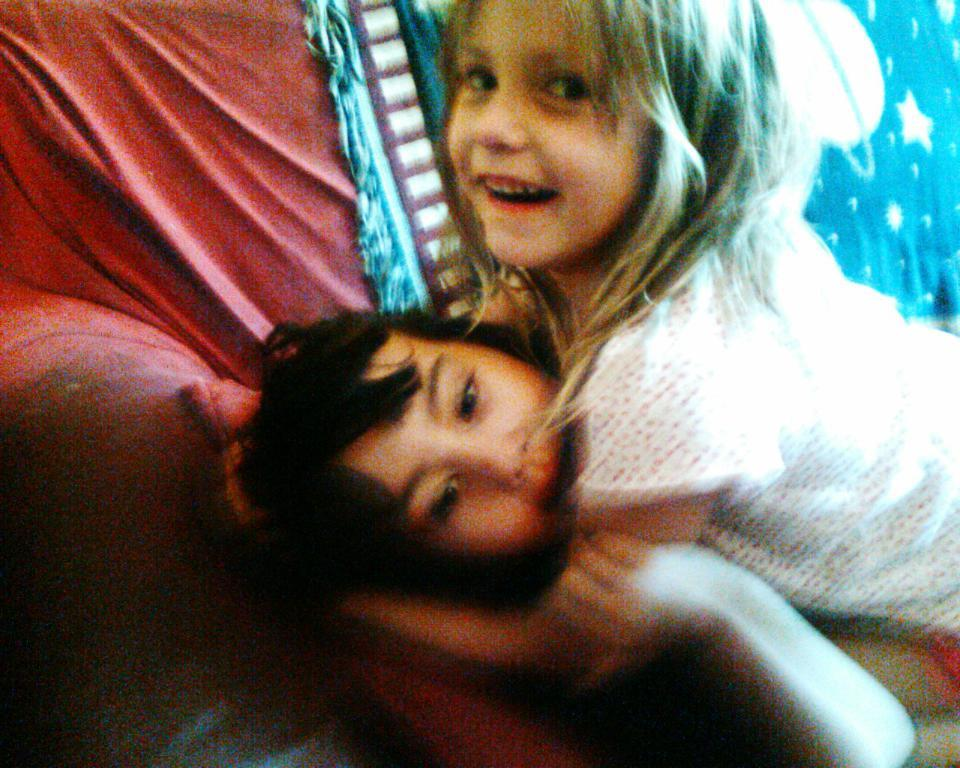How many kids are in the image? There are two kids in the image. What are the kids doing in the image? The kids are laying on a sofa. What color is the cloth on the sofa? There is a blue cloth on the sofa. What type of soap is the kids using to wash their hands in the image? There is no soap or hand washing activity depicted in the image. 